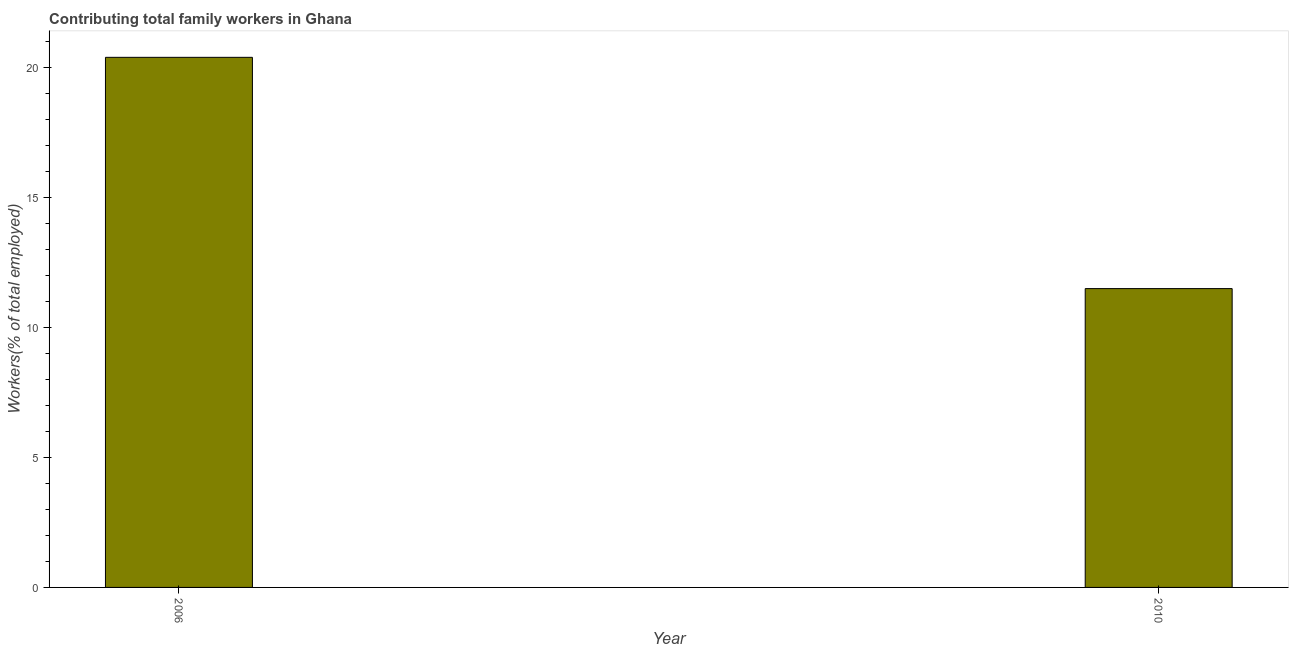Does the graph contain grids?
Your answer should be compact. No. What is the title of the graph?
Ensure brevity in your answer.  Contributing total family workers in Ghana. What is the label or title of the X-axis?
Ensure brevity in your answer.  Year. What is the label or title of the Y-axis?
Your answer should be compact. Workers(% of total employed). What is the contributing family workers in 2006?
Ensure brevity in your answer.  20.4. Across all years, what is the maximum contributing family workers?
Provide a short and direct response. 20.4. Across all years, what is the minimum contributing family workers?
Ensure brevity in your answer.  11.5. In which year was the contributing family workers maximum?
Give a very brief answer. 2006. In which year was the contributing family workers minimum?
Provide a short and direct response. 2010. What is the sum of the contributing family workers?
Give a very brief answer. 31.9. What is the average contributing family workers per year?
Make the answer very short. 15.95. What is the median contributing family workers?
Offer a very short reply. 15.95. What is the ratio of the contributing family workers in 2006 to that in 2010?
Your answer should be very brief. 1.77. How many years are there in the graph?
Your response must be concise. 2. What is the difference between two consecutive major ticks on the Y-axis?
Your answer should be very brief. 5. Are the values on the major ticks of Y-axis written in scientific E-notation?
Keep it short and to the point. No. What is the Workers(% of total employed) in 2006?
Your answer should be compact. 20.4. What is the difference between the Workers(% of total employed) in 2006 and 2010?
Make the answer very short. 8.9. What is the ratio of the Workers(% of total employed) in 2006 to that in 2010?
Keep it short and to the point. 1.77. 